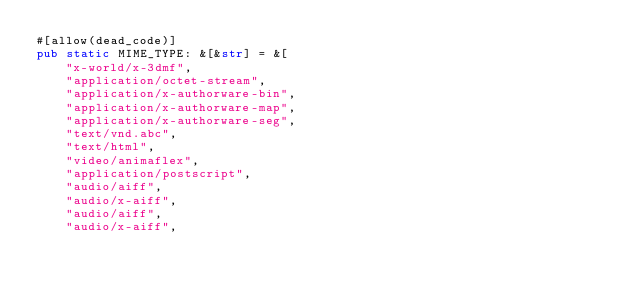<code> <loc_0><loc_0><loc_500><loc_500><_Rust_>#[allow(dead_code)]
pub static MIME_TYPE: &[&str] = &[
    "x-world/x-3dmf",
    "application/octet-stream",
    "application/x-authorware-bin",
    "application/x-authorware-map",
    "application/x-authorware-seg",
    "text/vnd.abc",
    "text/html",
    "video/animaflex",
    "application/postscript",
    "audio/aiff",
    "audio/x-aiff",
    "audio/aiff",
    "audio/x-aiff",</code> 